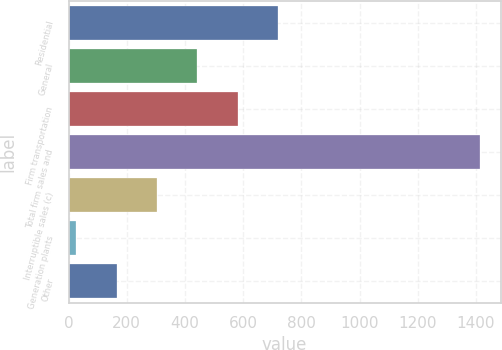Convert chart to OTSL. <chart><loc_0><loc_0><loc_500><loc_500><bar_chart><fcel>Residential<fcel>General<fcel>Firm transportation<fcel>Total firm sales and<fcel>Interruptible sales (c)<fcel>Generation plants<fcel>Other<nl><fcel>720<fcel>442.4<fcel>581.2<fcel>1414<fcel>303.6<fcel>26<fcel>164.8<nl></chart> 